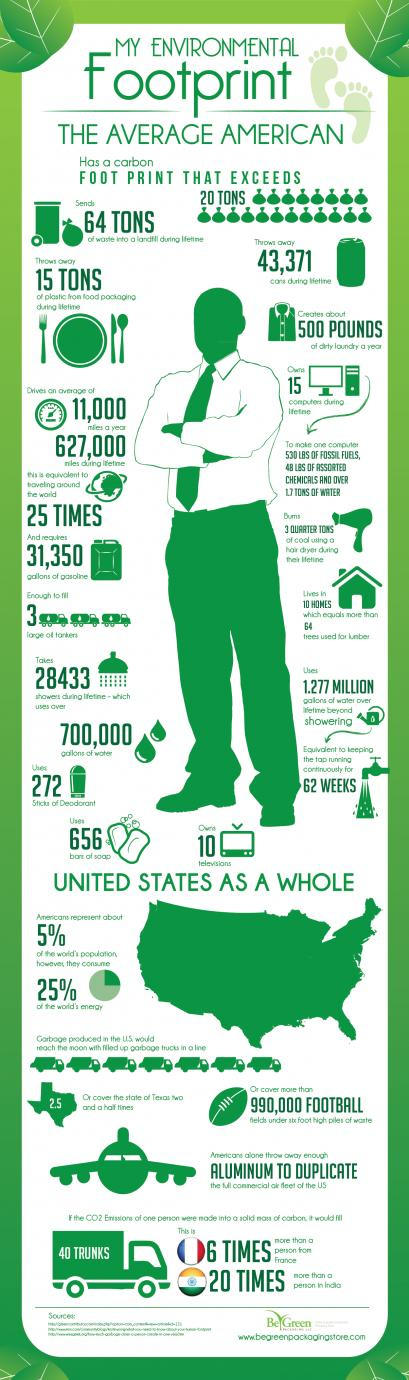List a handful of essential elements in this visual. It is estimated that approximately 75% of the world's energy is not consumed by Americans. 